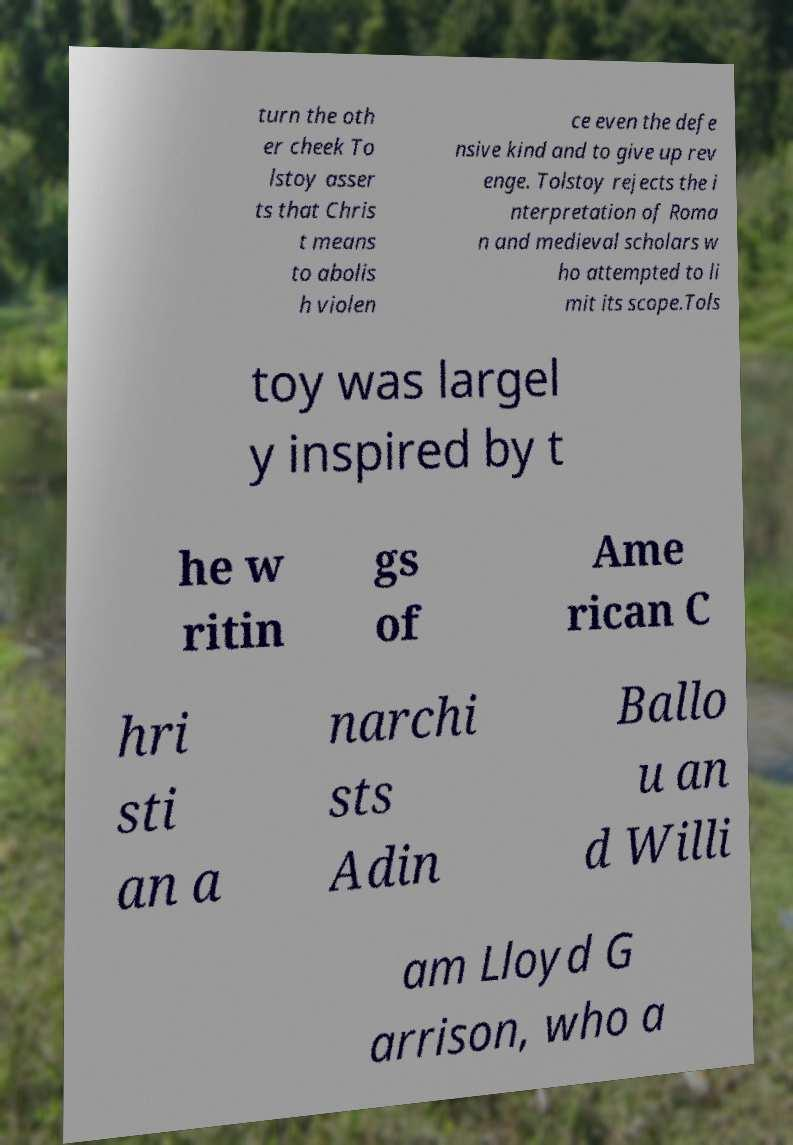Can you accurately transcribe the text from the provided image for me? turn the oth er cheek To lstoy asser ts that Chris t means to abolis h violen ce even the defe nsive kind and to give up rev enge. Tolstoy rejects the i nterpretation of Roma n and medieval scholars w ho attempted to li mit its scope.Tols toy was largel y inspired by t he w ritin gs of Ame rican C hri sti an a narchi sts Adin Ballo u an d Willi am Lloyd G arrison, who a 